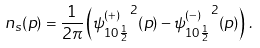Convert formula to latex. <formula><loc_0><loc_0><loc_500><loc_500>n _ { s } ( p ) = \frac { 1 } { 2 \pi } \left ( { \psi ^ { ( + ) } _ { 1 0 \frac { 1 } { 2 } } } ^ { 2 } ( p ) - { \psi ^ { ( - ) } _ { 1 0 \frac { 1 } { 2 } } } ^ { 2 } ( p ) \right ) \, .</formula> 